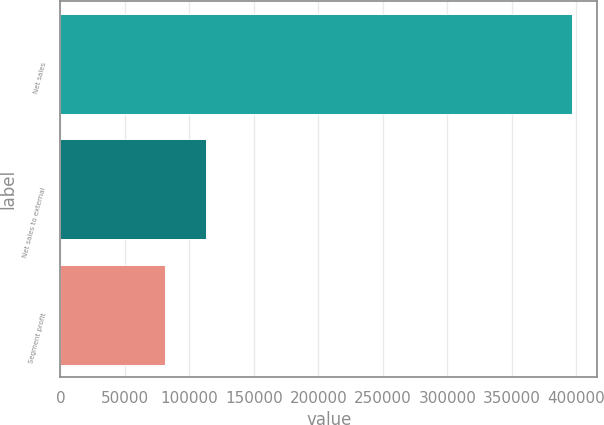<chart> <loc_0><loc_0><loc_500><loc_500><bar_chart><fcel>Net sales<fcel>Net sales to external<fcel>Segment profit<nl><fcel>396269<fcel>112955<fcel>81476<nl></chart> 